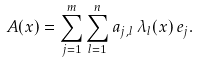Convert formula to latex. <formula><loc_0><loc_0><loc_500><loc_500>A ( x ) = \sum _ { j = 1 } ^ { m } \sum _ { l = 1 } ^ { n } a _ { j , l } \, \lambda _ { l } ( x ) \, e _ { j } .</formula> 